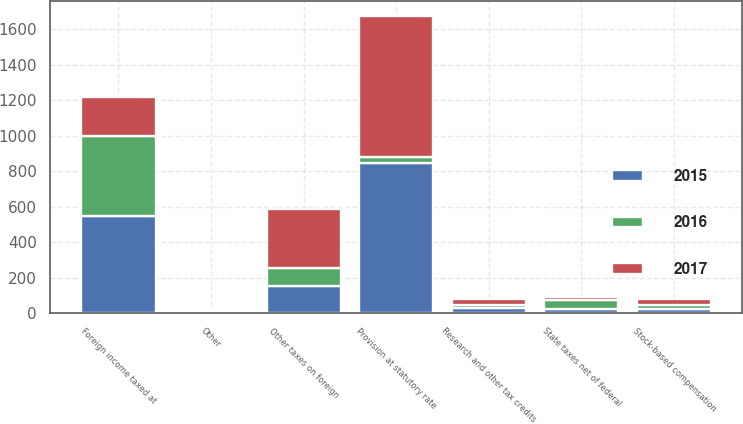<chart> <loc_0><loc_0><loc_500><loc_500><stacked_bar_chart><ecel><fcel>Provision at statutory rate<fcel>Foreign income taxed at<fcel>Other taxes on foreign<fcel>Stock-based compensation<fcel>State taxes net of federal<fcel>Research and other tax credits<fcel>Other<nl><fcel>2017<fcel>797<fcel>217<fcel>330<fcel>33<fcel>13<fcel>35<fcel>12<nl><fcel>2016<fcel>34<fcel>451<fcel>105<fcel>24<fcel>55<fcel>16<fcel>8<nl><fcel>2015<fcel>843<fcel>549<fcel>150<fcel>23<fcel>20<fcel>27<fcel>1<nl></chart> 